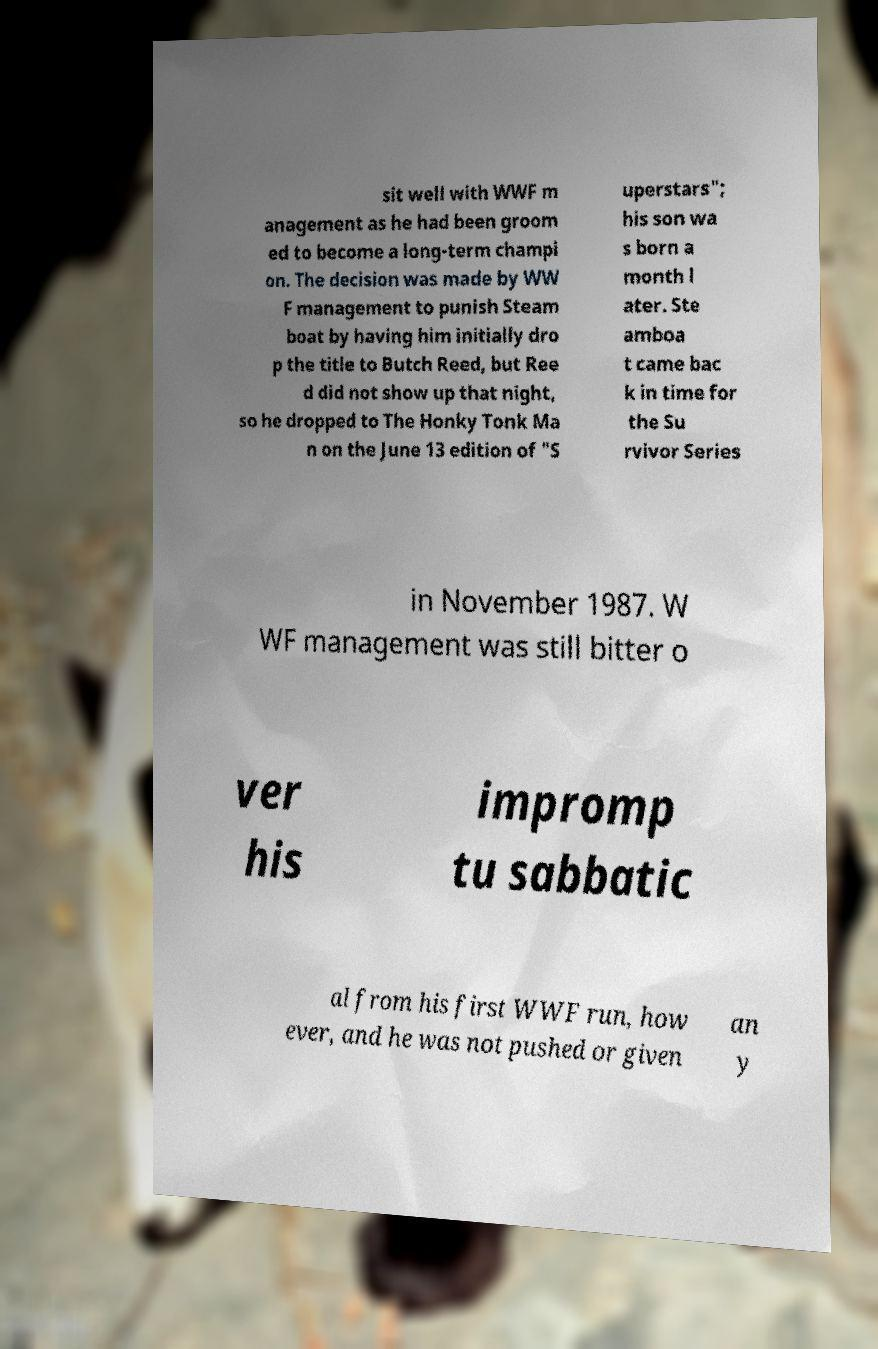Can you read and provide the text displayed in the image?This photo seems to have some interesting text. Can you extract and type it out for me? sit well with WWF m anagement as he had been groom ed to become a long-term champi on. The decision was made by WW F management to punish Steam boat by having him initially dro p the title to Butch Reed, but Ree d did not show up that night, so he dropped to The Honky Tonk Ma n on the June 13 edition of "S uperstars"; his son wa s born a month l ater. Ste amboa t came bac k in time for the Su rvivor Series in November 1987. W WF management was still bitter o ver his impromp tu sabbatic al from his first WWF run, how ever, and he was not pushed or given an y 